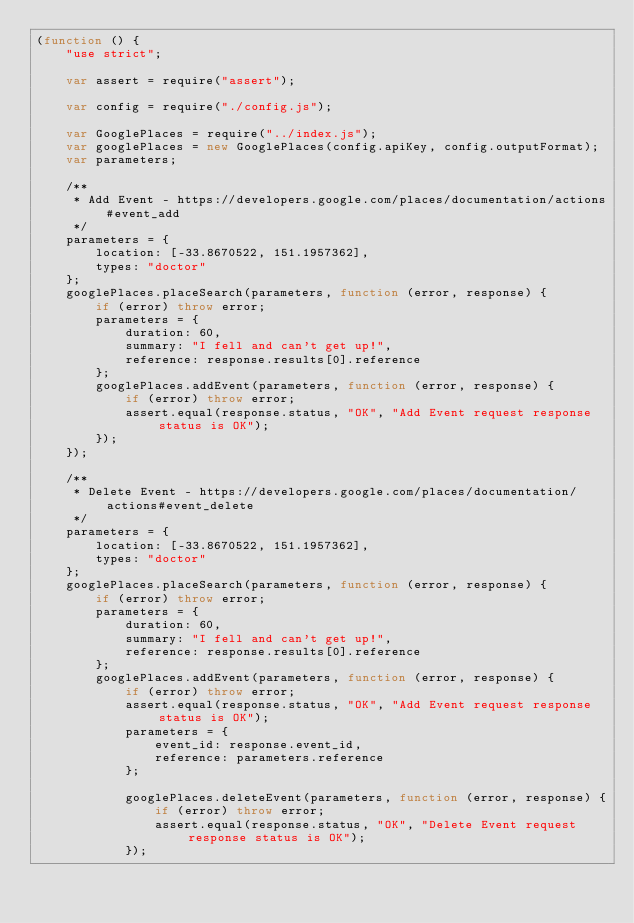<code> <loc_0><loc_0><loc_500><loc_500><_JavaScript_>(function () {
    "use strict";

    var assert = require("assert");

    var config = require("./config.js");

    var GooglePlaces = require("../index.js");
    var googlePlaces = new GooglePlaces(config.apiKey, config.outputFormat);
    var parameters;

    /**
     * Add Event - https://developers.google.com/places/documentation/actions#event_add
     */
    parameters = {
        location: [-33.8670522, 151.1957362],
        types: "doctor"
    };
    googlePlaces.placeSearch(parameters, function (error, response) {
        if (error) throw error;
        parameters = {
            duration: 60,
            summary: "I fell and can't get up!",
            reference: response.results[0].reference
        };
        googlePlaces.addEvent(parameters, function (error, response) {
            if (error) throw error;
            assert.equal(response.status, "OK", "Add Event request response status is OK");
        });
    });

    /**
     * Delete Event - https://developers.google.com/places/documentation/actions#event_delete
     */
    parameters = {
        location: [-33.8670522, 151.1957362],
        types: "doctor"
    };
    googlePlaces.placeSearch(parameters, function (error, response) {
        if (error) throw error;
        parameters = {
            duration: 60,
            summary: "I fell and can't get up!",
            reference: response.results[0].reference
        };
        googlePlaces.addEvent(parameters, function (error, response) {
            if (error) throw error;
            assert.equal(response.status, "OK", "Add Event request response status is OK");
            parameters = {
                event_id: response.event_id,
                reference: parameters.reference
            };

            googlePlaces.deleteEvent(parameters, function (error, response) {
                if (error) throw error;
                assert.equal(response.status, "OK", "Delete Event request response status is OK");
            });</code> 